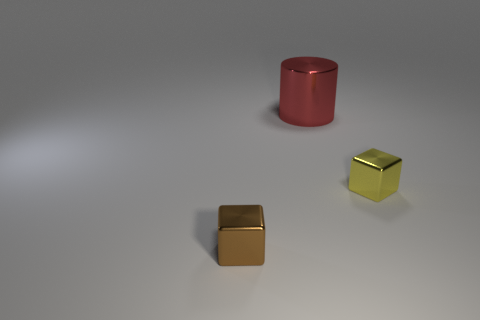Add 3 red metal cylinders. How many objects exist? 6 Subtract all cylinders. How many objects are left? 2 Add 2 small brown objects. How many small brown objects are left? 3 Add 3 blue metallic cylinders. How many blue metallic cylinders exist? 3 Subtract all yellow cubes. How many cubes are left? 1 Subtract 0 blue cylinders. How many objects are left? 3 Subtract 1 cubes. How many cubes are left? 1 Subtract all brown cylinders. Subtract all blue spheres. How many cylinders are left? 1 Subtract all brown balls. How many brown blocks are left? 1 Subtract all metal objects. Subtract all blue rubber spheres. How many objects are left? 0 